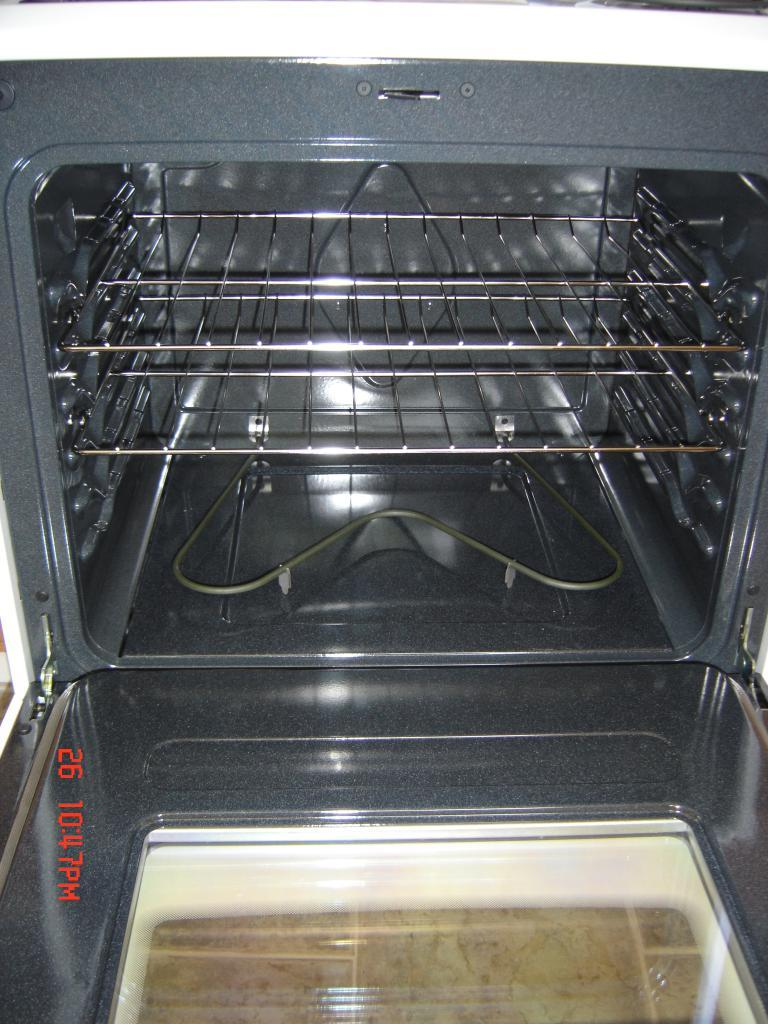What type of appliance can be seen in the image? There is an oven in the image. Is there any additional information displayed in the image? Yes, there is a date and time displayed on the left side of the image. What type of bushes can be seen growing around the oven in the image? There are no bushes visible in the image; it only shows an oven and a date and time display. 